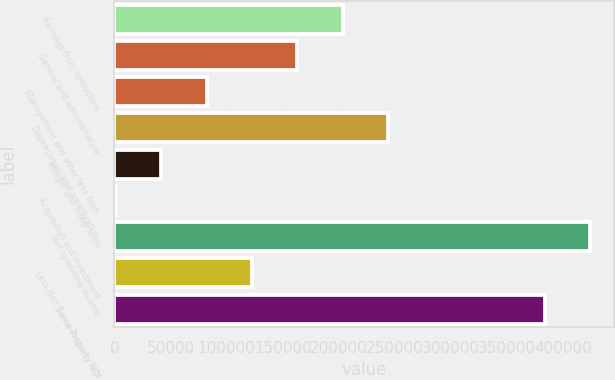<chart> <loc_0><loc_0><loc_500><loc_500><bar_chart><fcel>Earnings from operations<fcel>General and administrative<fcel>Management and other fees from<fcel>Depreciation and amortization<fcel>Merger and integration<fcel>Acquisition and investment<fcel>Net operating income<fcel>Less Non Same-Property NOI<fcel>Same-Property NOI<nl><fcel>203576<fcel>163093<fcel>82127<fcel>244059<fcel>41644<fcel>1161<fcel>423875<fcel>122610<fcel>383392<nl></chart> 